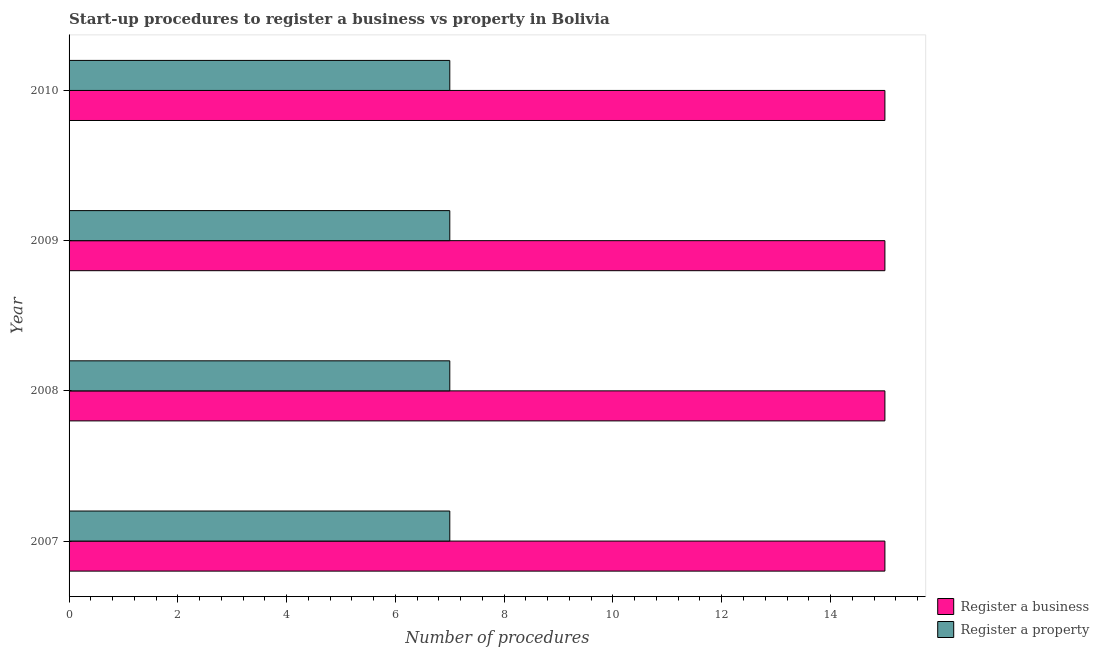How many different coloured bars are there?
Offer a terse response. 2. Are the number of bars per tick equal to the number of legend labels?
Ensure brevity in your answer.  Yes. How many bars are there on the 1st tick from the top?
Your response must be concise. 2. What is the number of procedures to register a property in 2008?
Your answer should be very brief. 7. Across all years, what is the maximum number of procedures to register a property?
Keep it short and to the point. 7. Across all years, what is the minimum number of procedures to register a property?
Provide a succinct answer. 7. In which year was the number of procedures to register a business maximum?
Ensure brevity in your answer.  2007. In which year was the number of procedures to register a business minimum?
Offer a terse response. 2007. What is the total number of procedures to register a property in the graph?
Provide a short and direct response. 28. What is the difference between the number of procedures to register a property in 2009 and the number of procedures to register a business in 2008?
Make the answer very short. -8. In the year 2009, what is the difference between the number of procedures to register a property and number of procedures to register a business?
Offer a terse response. -8. What is the ratio of the number of procedures to register a business in 2007 to that in 2008?
Give a very brief answer. 1. Is the number of procedures to register a property in 2009 less than that in 2010?
Ensure brevity in your answer.  No. Is the difference between the number of procedures to register a property in 2008 and 2010 greater than the difference between the number of procedures to register a business in 2008 and 2010?
Your answer should be compact. No. What is the difference between the highest and the second highest number of procedures to register a property?
Ensure brevity in your answer.  0. Is the sum of the number of procedures to register a business in 2007 and 2009 greater than the maximum number of procedures to register a property across all years?
Your answer should be very brief. Yes. What does the 1st bar from the top in 2009 represents?
Ensure brevity in your answer.  Register a property. What does the 2nd bar from the bottom in 2010 represents?
Offer a terse response. Register a property. What is the difference between two consecutive major ticks on the X-axis?
Your response must be concise. 2. Does the graph contain grids?
Provide a succinct answer. No. Where does the legend appear in the graph?
Ensure brevity in your answer.  Bottom right. How are the legend labels stacked?
Give a very brief answer. Vertical. What is the title of the graph?
Ensure brevity in your answer.  Start-up procedures to register a business vs property in Bolivia. What is the label or title of the X-axis?
Your answer should be very brief. Number of procedures. What is the label or title of the Y-axis?
Ensure brevity in your answer.  Year. What is the Number of procedures of Register a property in 2007?
Offer a terse response. 7. What is the Number of procedures of Register a property in 2008?
Your response must be concise. 7. What is the Number of procedures in Register a business in 2010?
Provide a succinct answer. 15. What is the Number of procedures of Register a property in 2010?
Your response must be concise. 7. Across all years, what is the maximum Number of procedures in Register a business?
Your response must be concise. 15. What is the total Number of procedures in Register a property in the graph?
Offer a terse response. 28. What is the difference between the Number of procedures in Register a business in 2007 and that in 2008?
Provide a short and direct response. 0. What is the difference between the Number of procedures in Register a property in 2007 and that in 2008?
Provide a succinct answer. 0. What is the difference between the Number of procedures of Register a business in 2007 and that in 2009?
Ensure brevity in your answer.  0. What is the difference between the Number of procedures of Register a property in 2007 and that in 2009?
Offer a very short reply. 0. What is the difference between the Number of procedures of Register a property in 2007 and that in 2010?
Your answer should be compact. 0. What is the difference between the Number of procedures of Register a property in 2008 and that in 2009?
Your answer should be very brief. 0. What is the difference between the Number of procedures of Register a business in 2008 and that in 2010?
Your response must be concise. 0. What is the difference between the Number of procedures of Register a property in 2009 and that in 2010?
Offer a terse response. 0. What is the difference between the Number of procedures in Register a business in 2007 and the Number of procedures in Register a property in 2009?
Your response must be concise. 8. What is the difference between the Number of procedures of Register a business in 2008 and the Number of procedures of Register a property in 2009?
Offer a very short reply. 8. What is the difference between the Number of procedures in Register a business in 2008 and the Number of procedures in Register a property in 2010?
Make the answer very short. 8. What is the difference between the Number of procedures of Register a business in 2009 and the Number of procedures of Register a property in 2010?
Provide a short and direct response. 8. What is the average Number of procedures in Register a business per year?
Give a very brief answer. 15. In the year 2007, what is the difference between the Number of procedures in Register a business and Number of procedures in Register a property?
Your answer should be compact. 8. In the year 2009, what is the difference between the Number of procedures of Register a business and Number of procedures of Register a property?
Ensure brevity in your answer.  8. What is the ratio of the Number of procedures of Register a property in 2007 to that in 2008?
Offer a very short reply. 1. What is the ratio of the Number of procedures of Register a business in 2007 to that in 2009?
Your answer should be very brief. 1. What is the ratio of the Number of procedures in Register a property in 2007 to that in 2009?
Ensure brevity in your answer.  1. What is the ratio of the Number of procedures of Register a property in 2007 to that in 2010?
Offer a very short reply. 1. What is the ratio of the Number of procedures in Register a business in 2008 to that in 2009?
Provide a short and direct response. 1. What is the ratio of the Number of procedures of Register a property in 2008 to that in 2009?
Your answer should be very brief. 1. What is the ratio of the Number of procedures in Register a business in 2008 to that in 2010?
Your answer should be very brief. 1. What is the ratio of the Number of procedures in Register a property in 2008 to that in 2010?
Your response must be concise. 1. What is the ratio of the Number of procedures of Register a business in 2009 to that in 2010?
Provide a short and direct response. 1. What is the difference between the highest and the second highest Number of procedures in Register a business?
Keep it short and to the point. 0. What is the difference between the highest and the second highest Number of procedures of Register a property?
Provide a short and direct response. 0. What is the difference between the highest and the lowest Number of procedures of Register a business?
Offer a terse response. 0. What is the difference between the highest and the lowest Number of procedures of Register a property?
Provide a succinct answer. 0. 